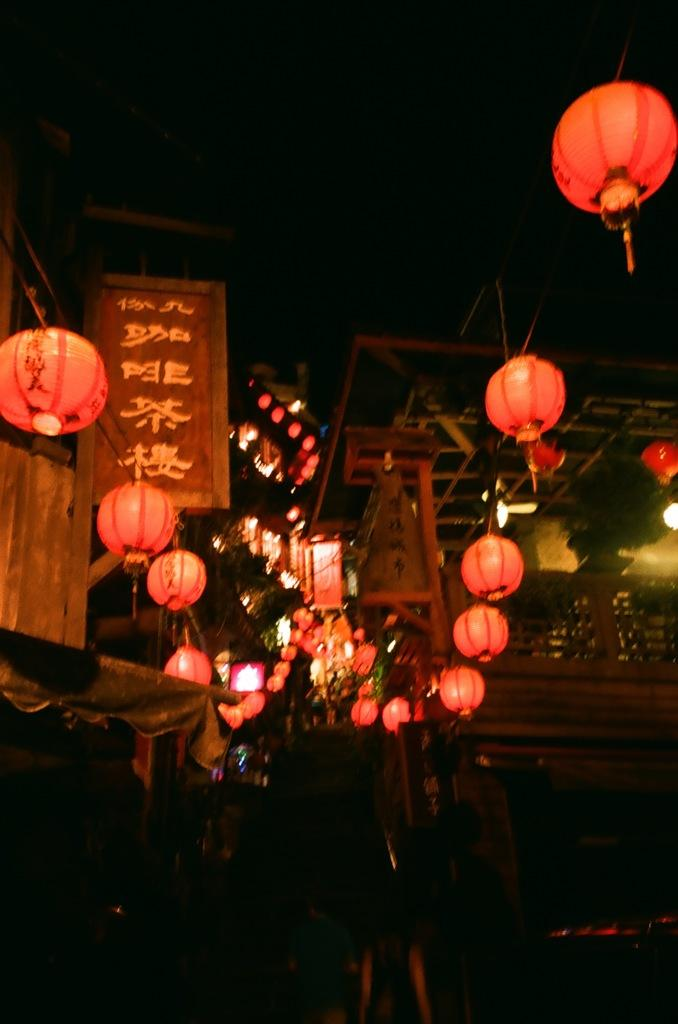What type of decorations can be seen in the image? There are paper lanterns in the image. What type of structures are present in the image? There are wooden houses in the image. What are the people in the image doing? People are walking in the image. What type of line can be seen connecting the paper lanterns in the image? There is no line connecting the paper lanterns in the image. Where is the drain located in the image? There is no drain present in the image. 